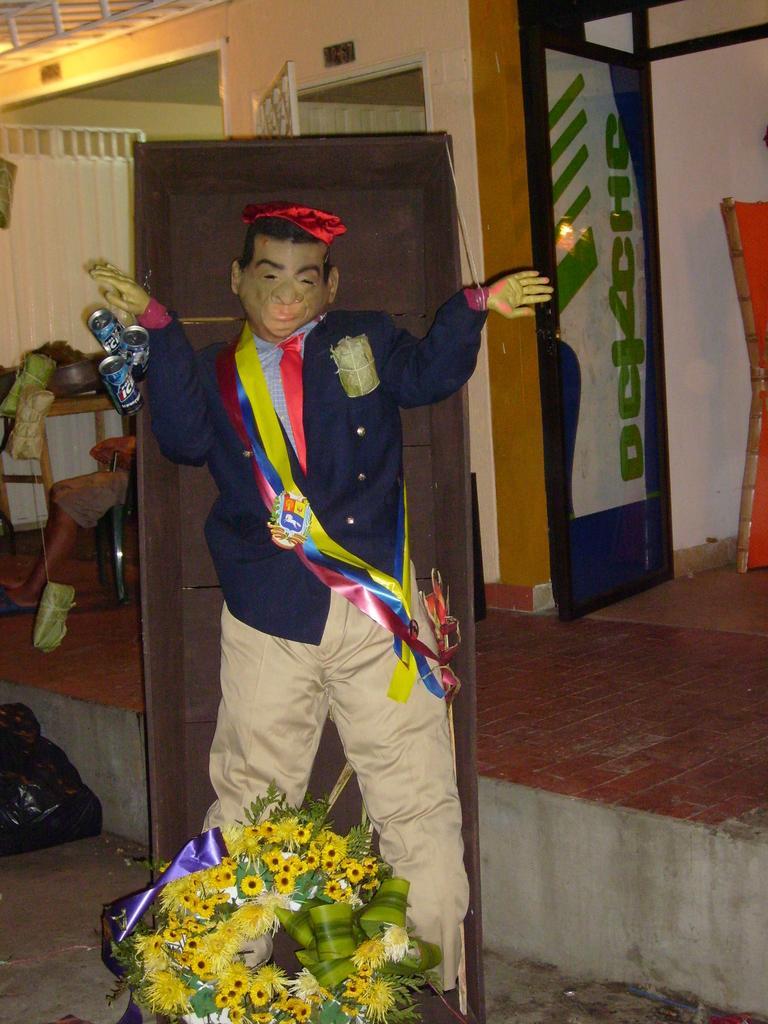Please provide a concise description of this image. In the center of the image we can see a depiction. On the left side of the image we can see a curtain, rod, a person is sitting on a chair, table. On the table we can see the objects. At the bottom of the image we can see the floor, flowers, leaves, plastic cover. In the background of the image we can see the doors, wall, boards, floor. At the top of the image we can see the rods, light, roof. 